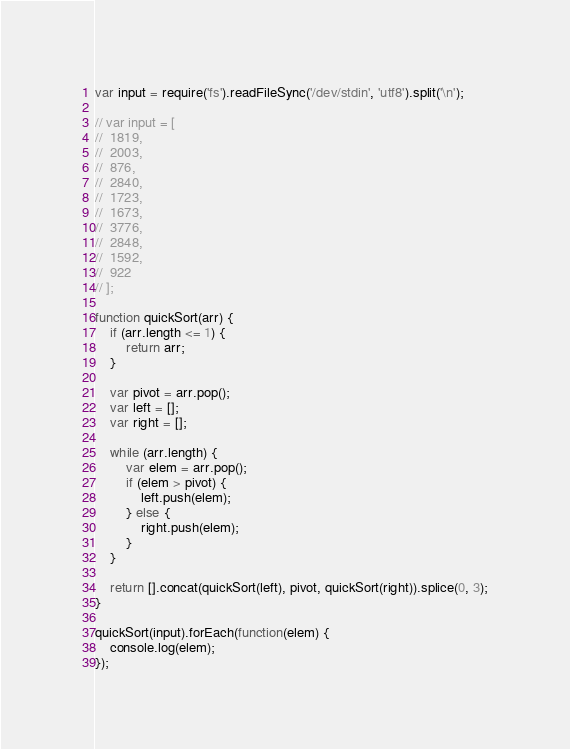<code> <loc_0><loc_0><loc_500><loc_500><_JavaScript_>var input = require('fs').readFileSync('/dev/stdin', 'utf8').split('\n');

// var input = [
// 	1819,
// 	2003,
// 	876,
// 	2840,
// 	1723,
// 	1673,
// 	3776,
// 	2848,
// 	1592,
// 	922
// ];

function quickSort(arr) {
	if (arr.length <= 1) {
		return arr;
	}

	var pivot = arr.pop();
	var left = [];
	var right = [];

	while (arr.length) {
		var elem = arr.pop();
		if (elem > pivot) {
			left.push(elem);
		} else {
			right.push(elem);
		}
	}

	return [].concat(quickSort(left), pivot, quickSort(right)).splice(0, 3);
}

quickSort(input).forEach(function(elem) {
	console.log(elem);
});</code> 